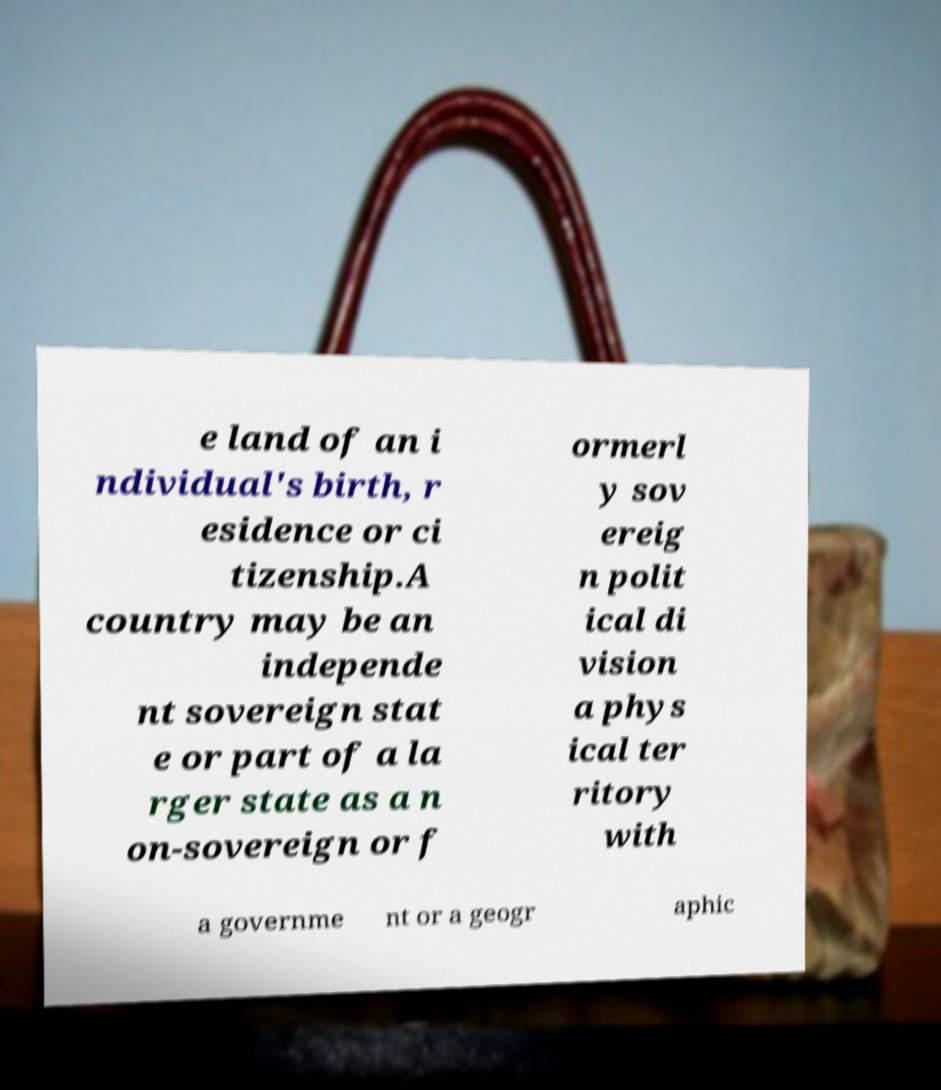What messages or text are displayed in this image? I need them in a readable, typed format. e land of an i ndividual's birth, r esidence or ci tizenship.A country may be an independe nt sovereign stat e or part of a la rger state as a n on-sovereign or f ormerl y sov ereig n polit ical di vision a phys ical ter ritory with a governme nt or a geogr aphic 